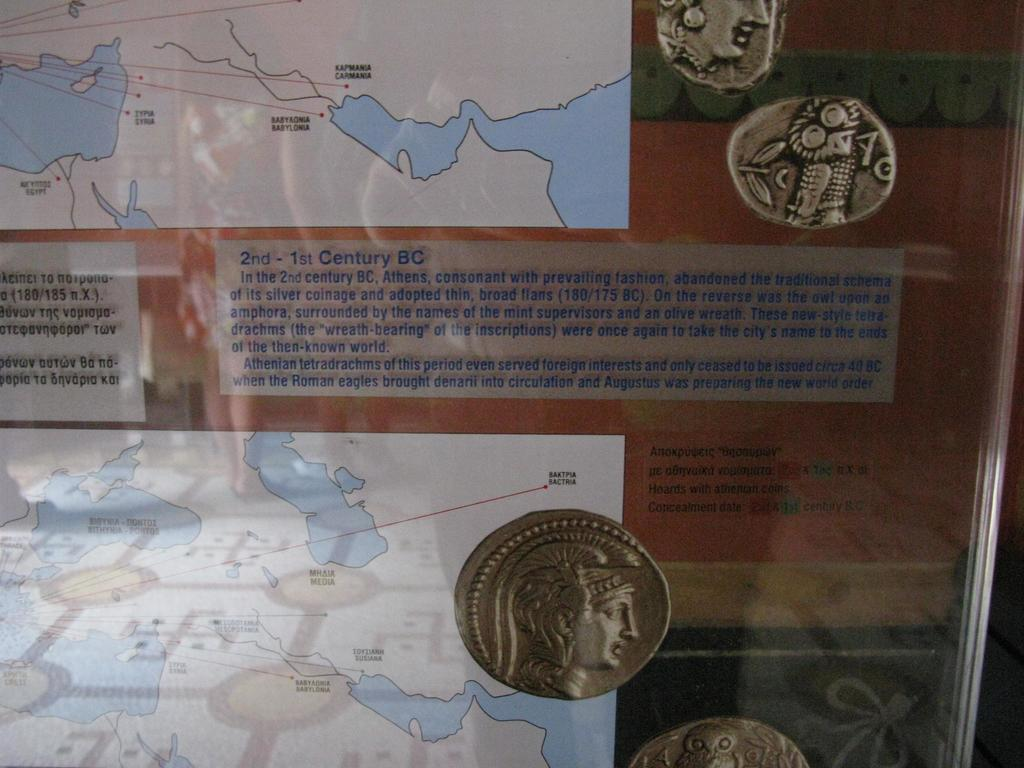<image>
Offer a succinct explanation of the picture presented. A museum display has a sign that starts with in the 2nd century. 